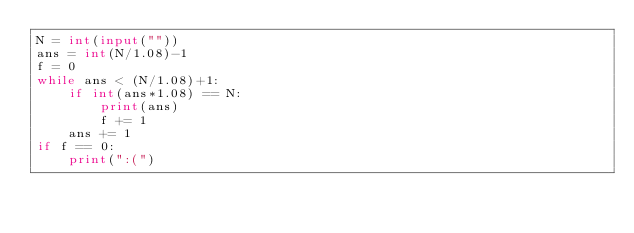Convert code to text. <code><loc_0><loc_0><loc_500><loc_500><_Python_>N = int(input(""))
ans = int(N/1.08)-1
f = 0
while ans < (N/1.08)+1:
    if int(ans*1.08) == N:
        print(ans)
        f += 1
    ans += 1
if f == 0:
    print(":(")</code> 